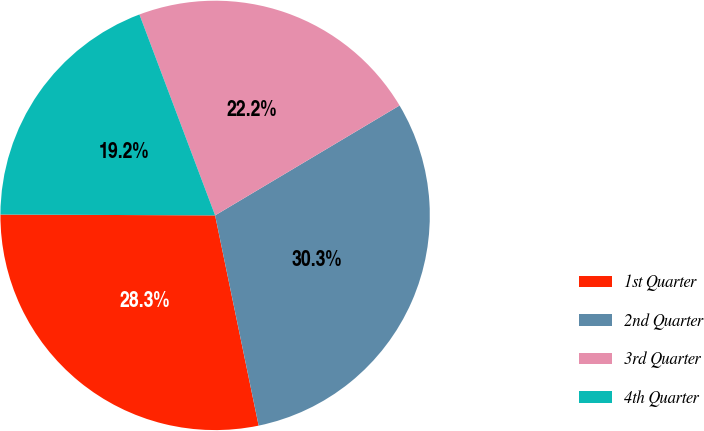Convert chart. <chart><loc_0><loc_0><loc_500><loc_500><pie_chart><fcel>1st Quarter<fcel>2nd Quarter<fcel>3rd Quarter<fcel>4th Quarter<nl><fcel>28.31%<fcel>30.3%<fcel>22.18%<fcel>19.2%<nl></chart> 